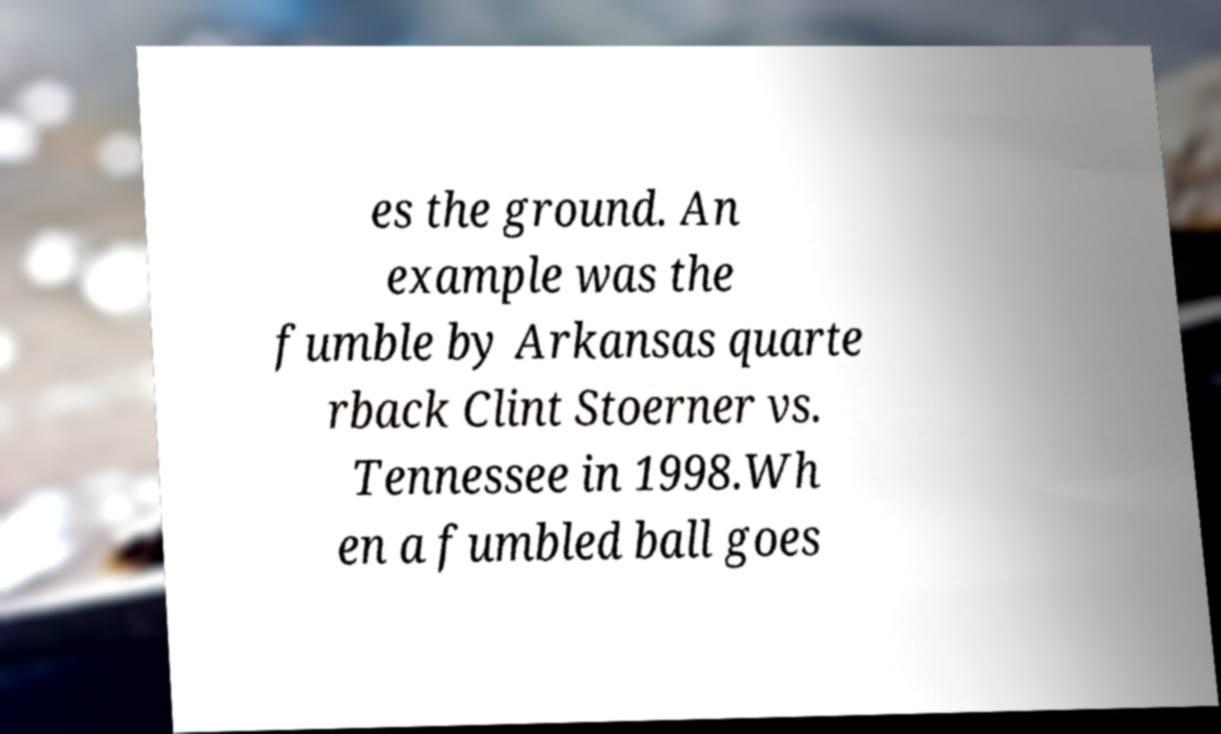There's text embedded in this image that I need extracted. Can you transcribe it verbatim? es the ground. An example was the fumble by Arkansas quarte rback Clint Stoerner vs. Tennessee in 1998.Wh en a fumbled ball goes 